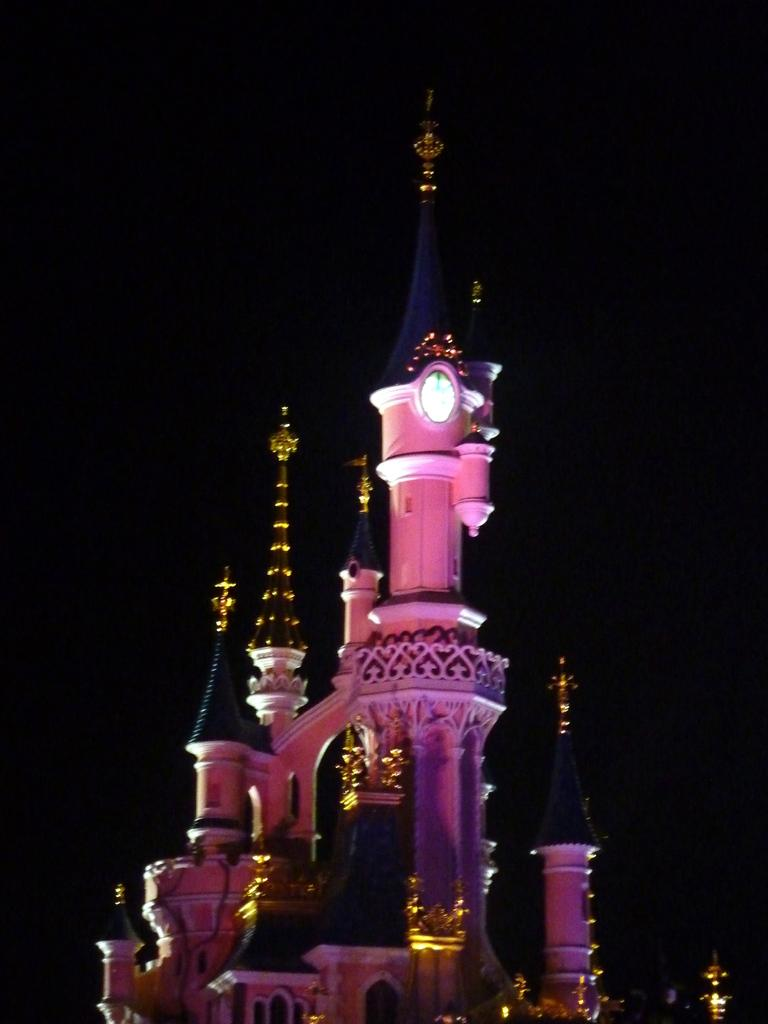Where was the picture taken? The picture was clicked outside. What is the main subject in the center of the image? There is a mansion-like object in the center of the image. Can you describe any specific architectural feature in the image? There is a spire visible in the image. What other objects can be seen in the image? There are other unspecified objects in the image. What type of cream is being used to expand the plastic objects in the image? There is no cream or plastic objects present in the image. 